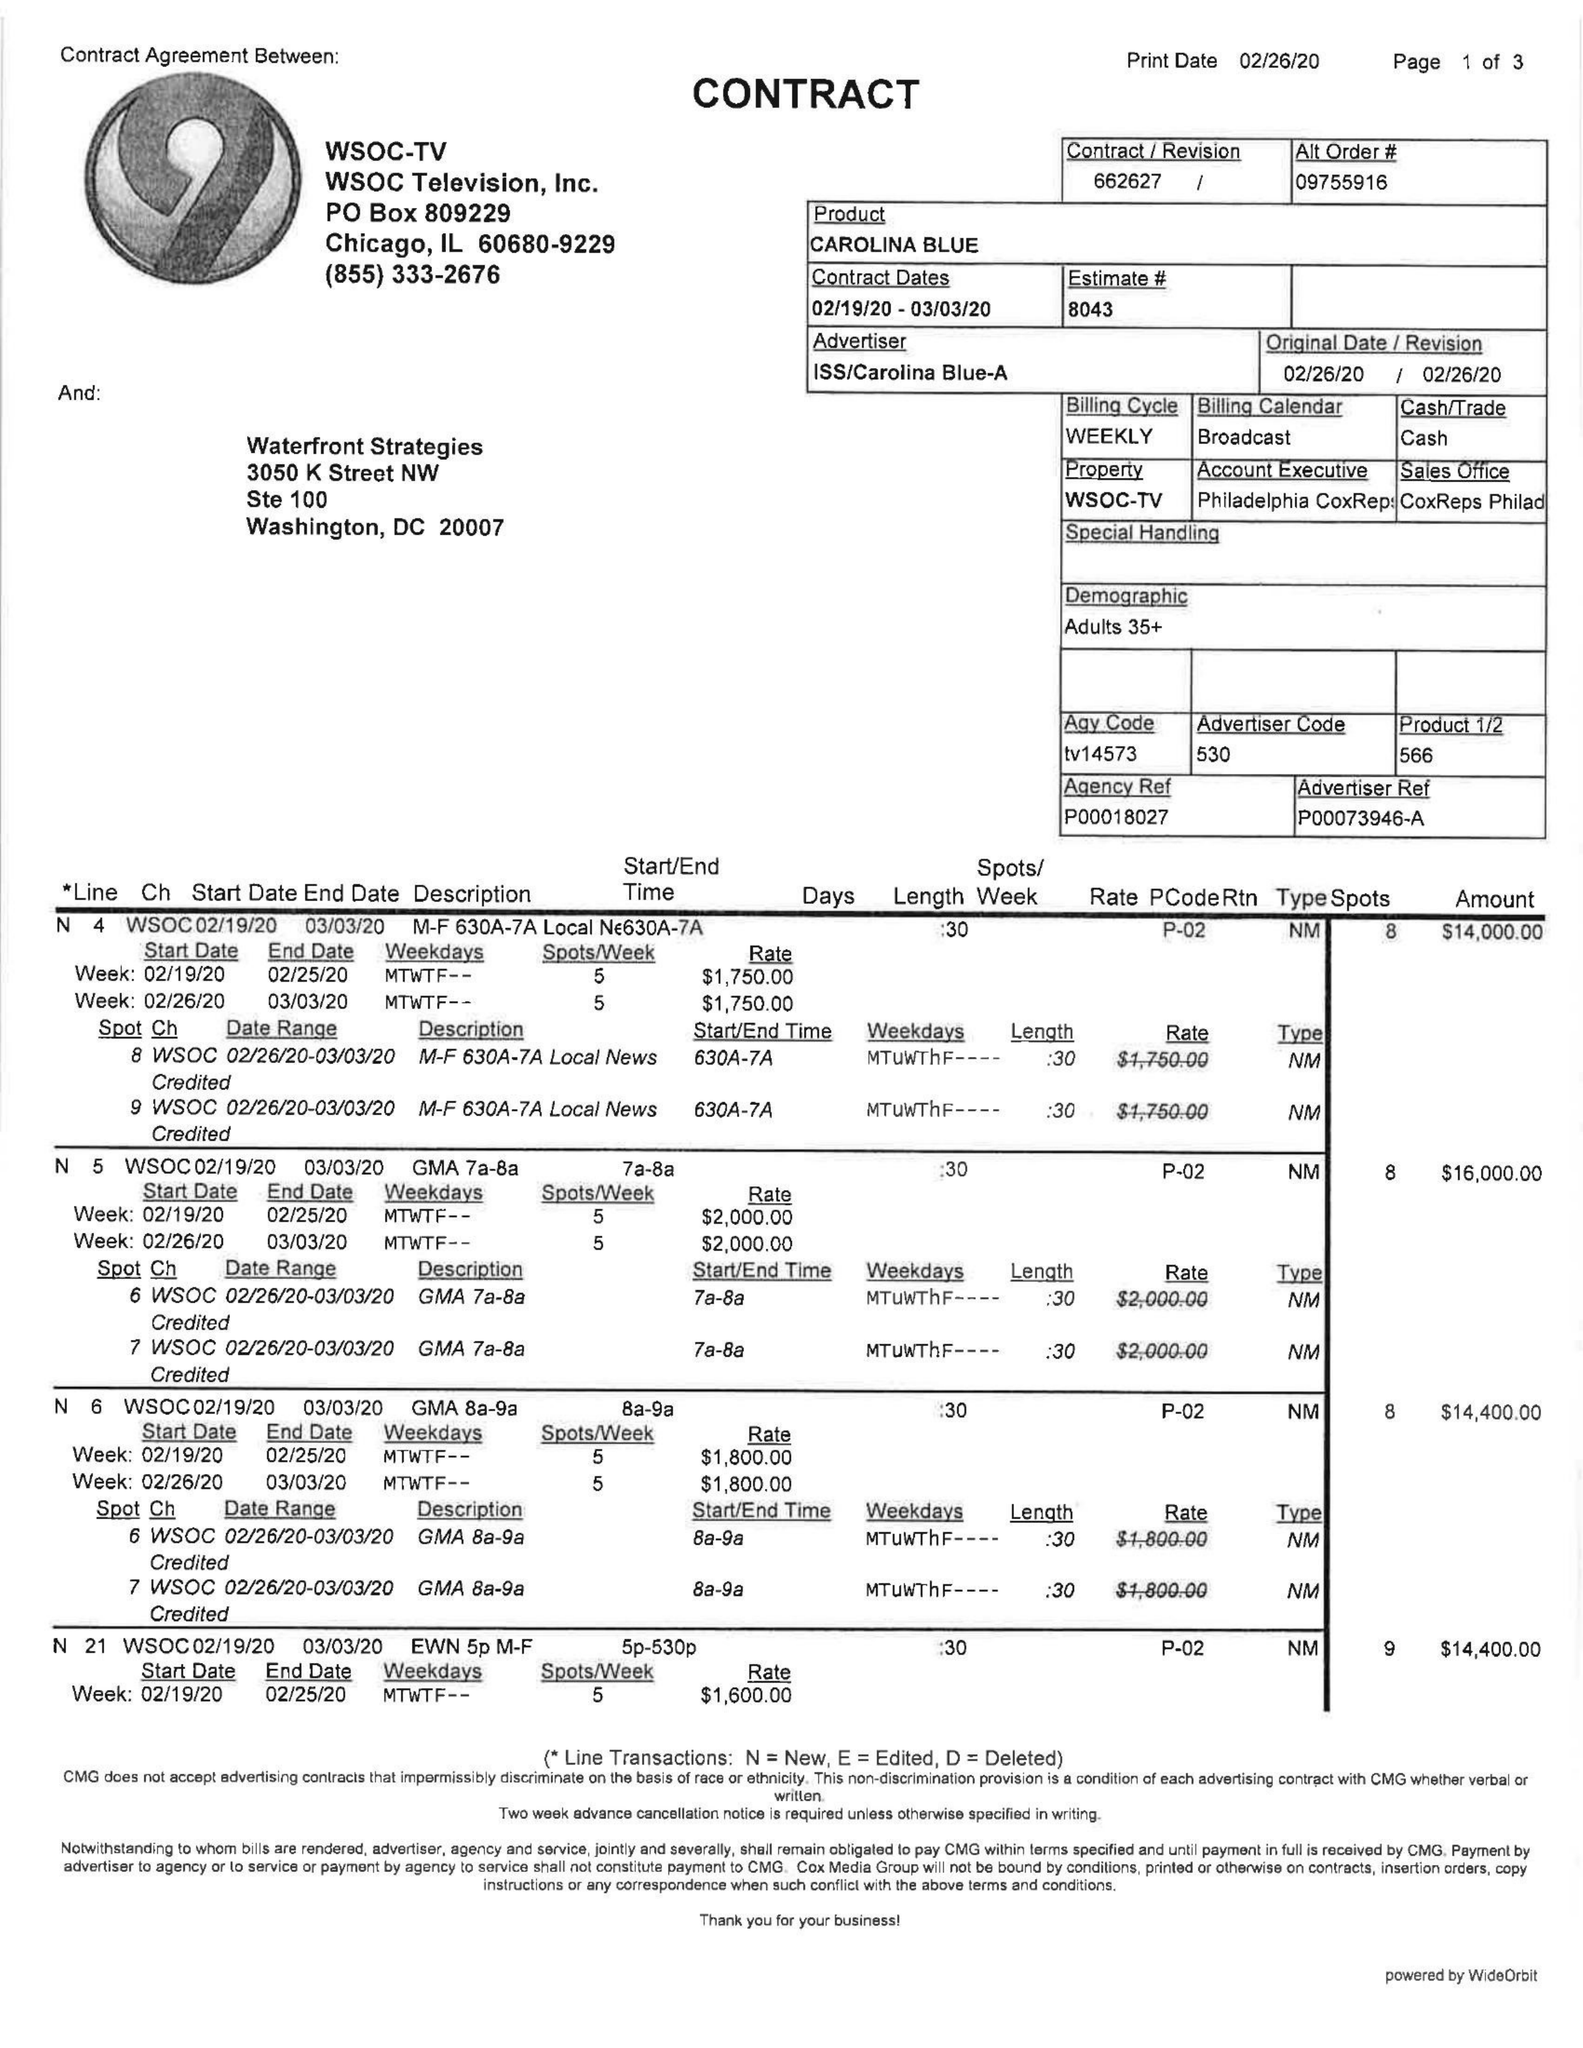What is the value for the advertiser?
Answer the question using a single word or phrase. ISS/CAROLINABLUE-A 